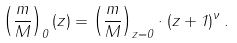<formula> <loc_0><loc_0><loc_500><loc_500>\left ( \frac { m } { M } \right ) _ { 0 } ( z ) = \left ( \frac { m } { M } \right ) _ { z = 0 } \cdot ( z + 1 ) ^ { \nu } \, .</formula> 